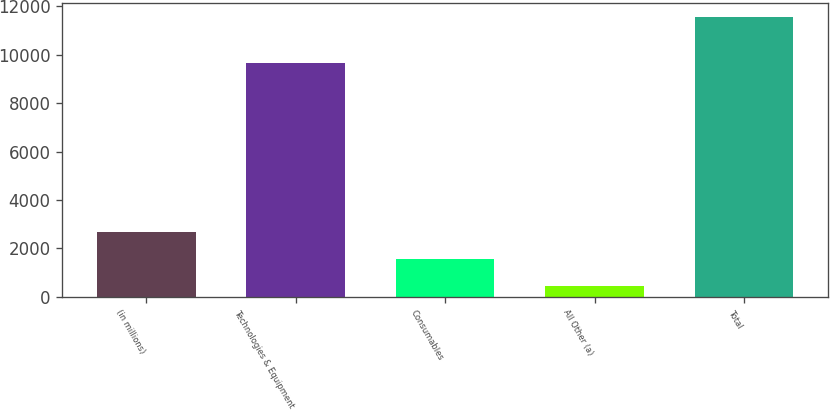Convert chart. <chart><loc_0><loc_0><loc_500><loc_500><bar_chart><fcel>(in millions)<fcel>Technologies & Equipment<fcel>Consumables<fcel>All Other (a)<fcel>Total<nl><fcel>2666.12<fcel>9667<fcel>1554.91<fcel>443.7<fcel>11555.8<nl></chart> 